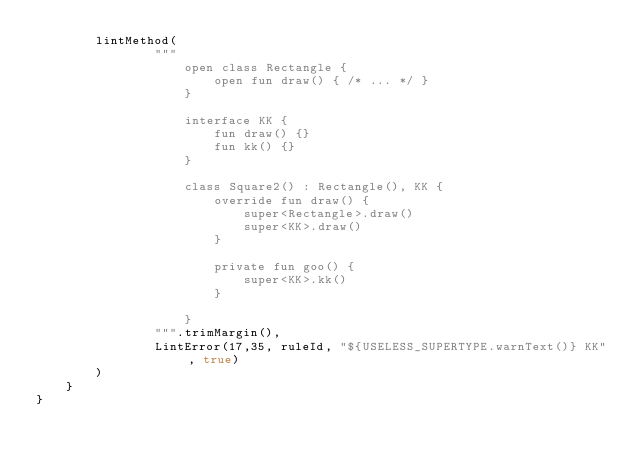Convert code to text. <code><loc_0><loc_0><loc_500><loc_500><_Kotlin_>        lintMethod(
                """
                    open class Rectangle {
                        open fun draw() { /* ... */ }
                    }
                    
                    interface KK {
                        fun draw() {}
                        fun kk() {}
                    }
                    
                    class Square2() : Rectangle(), KK {
                        override fun draw() {
                            super<Rectangle>.draw()
                            super<KK>.draw()
                        }
                        
                        private fun goo() {
                            super<KK>.kk()
                        }

                    }
                """.trimMargin(),
                LintError(17,35, ruleId, "${USELESS_SUPERTYPE.warnText()} KK", true)
        )
    }
}
</code> 